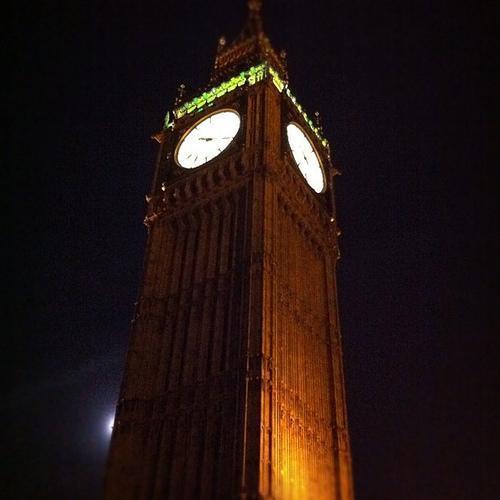How many clock faces are there?
Give a very brief answer. 2. 